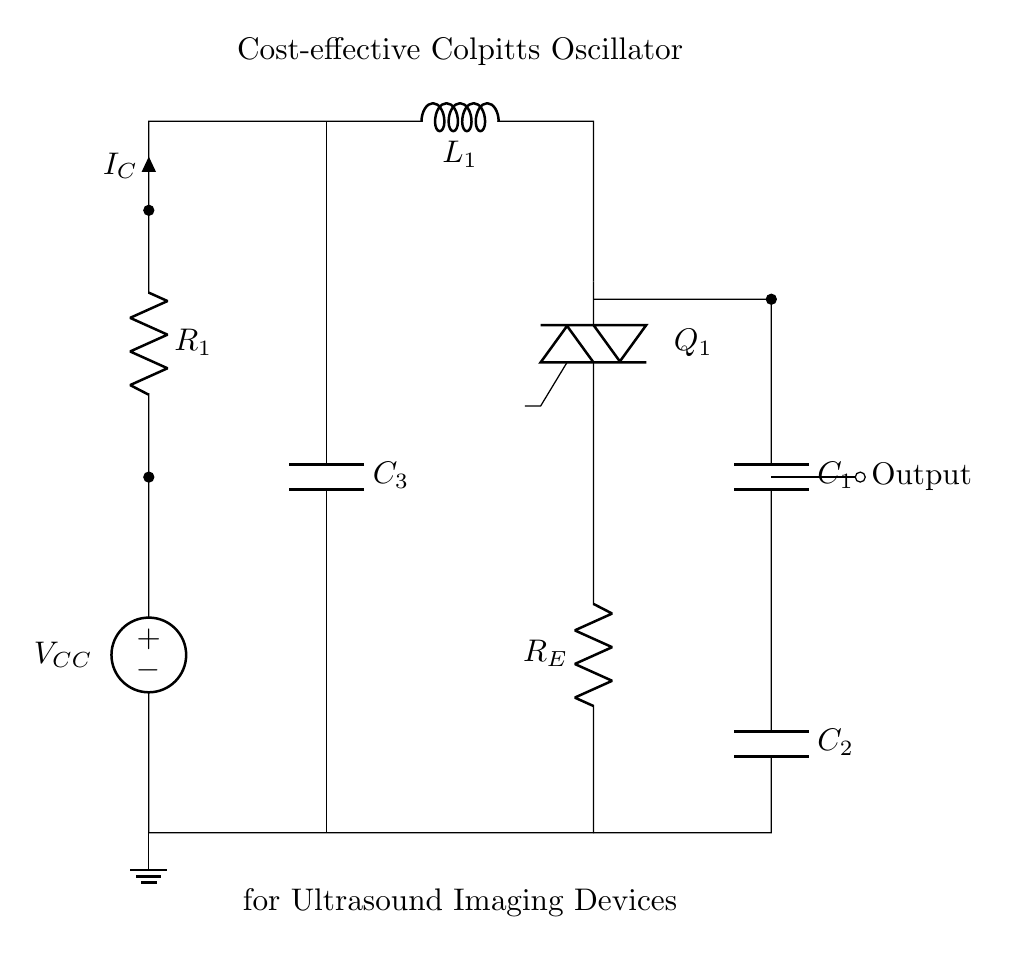What is the type of oscillator shown? The diagram depicts a Colpitts oscillator, characterized by its use of capacitors and an inductor forming a tank circuit. This specific type is often utilized for generating high-frequency signals.
Answer: Colpitts oscillator What is the output node labeled? The output node is indicated with the label "Output", which denotes where the oscillating signal can be taken from the circuit.
Answer: Output How many capacitors are in the circuit? The circuit contains three capacitors, identified as C1, C2, and C3, each serving to stabilize and control oscillation frequency along with the inductor.
Answer: Three What is the current flowing through the circuit labeled as? The current flowing through the circuit is labeled as Ic, which indicates the collector current related to the transistor's operation in the oscillator.
Answer: Ic What is the role of the inductor in this oscillator? The inductor (L1) works in conjunction with the capacitors to form a resonant frequency, thus determining the oscillation frequency of the circuit. This is a fundamental characteristic of oscillators to produce alternating currents.
Answer: Oscillation What is the importance of having both C1 and C2 in the circuit? C1 and C2 form a voltage divider setup which sets the condition for oscillation in relation to the capacitive reactance and determines the operating frequency of the oscillator, enhancing frequency stability.
Answer: Frequency stability What is the purpose of resistor R1 in the circuit? The resistor R1 is crucial for biasing the transistor Q1, ensuring it operates in the active region necessary for amplification and sustained oscillations within the circuit.
Answer: Biasing 